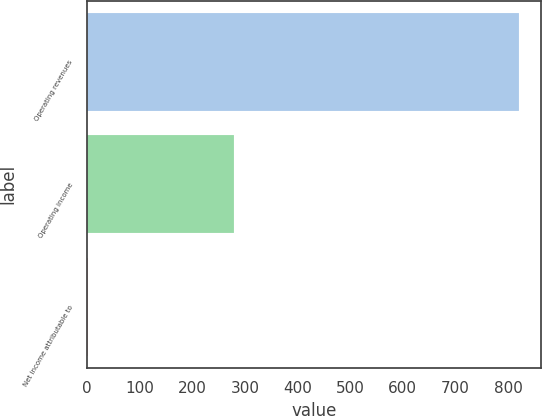Convert chart. <chart><loc_0><loc_0><loc_500><loc_500><bar_chart><fcel>Operating revenues<fcel>Operating income<fcel>Net income attributable to<nl><fcel>821<fcel>279<fcel>1<nl></chart> 